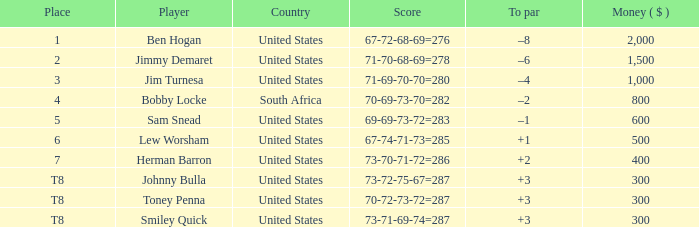What is the Money of the Player in Place 5? 600.0. 